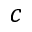<formula> <loc_0><loc_0><loc_500><loc_500>c</formula> 